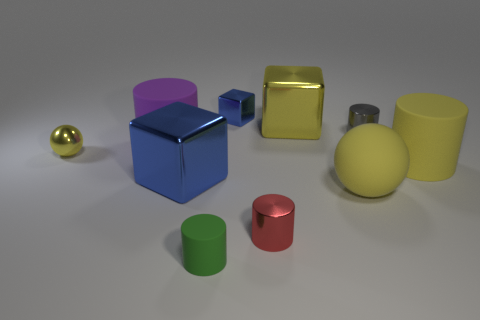Subtract all green cylinders. How many cylinders are left? 4 Subtract all brown cylinders. Subtract all gray blocks. How many cylinders are left? 5 Subtract all blocks. How many objects are left? 7 Add 4 small yellow metal balls. How many small yellow metal balls are left? 5 Add 3 small cyan matte balls. How many small cyan matte balls exist? 3 Subtract 0 gray spheres. How many objects are left? 10 Subtract all big metal things. Subtract all big blue things. How many objects are left? 7 